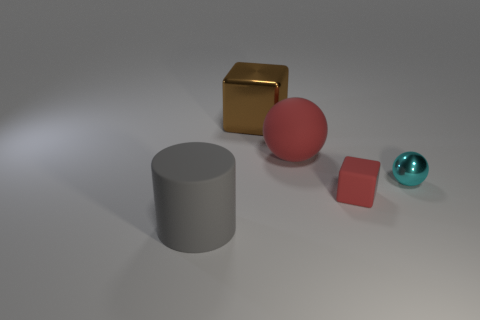Add 3 metallic cubes. How many objects exist? 8 Subtract all blocks. How many objects are left? 3 Subtract all gray objects. Subtract all matte cylinders. How many objects are left? 3 Add 2 rubber cylinders. How many rubber cylinders are left? 3 Add 2 gray objects. How many gray objects exist? 3 Subtract 0 blue blocks. How many objects are left? 5 